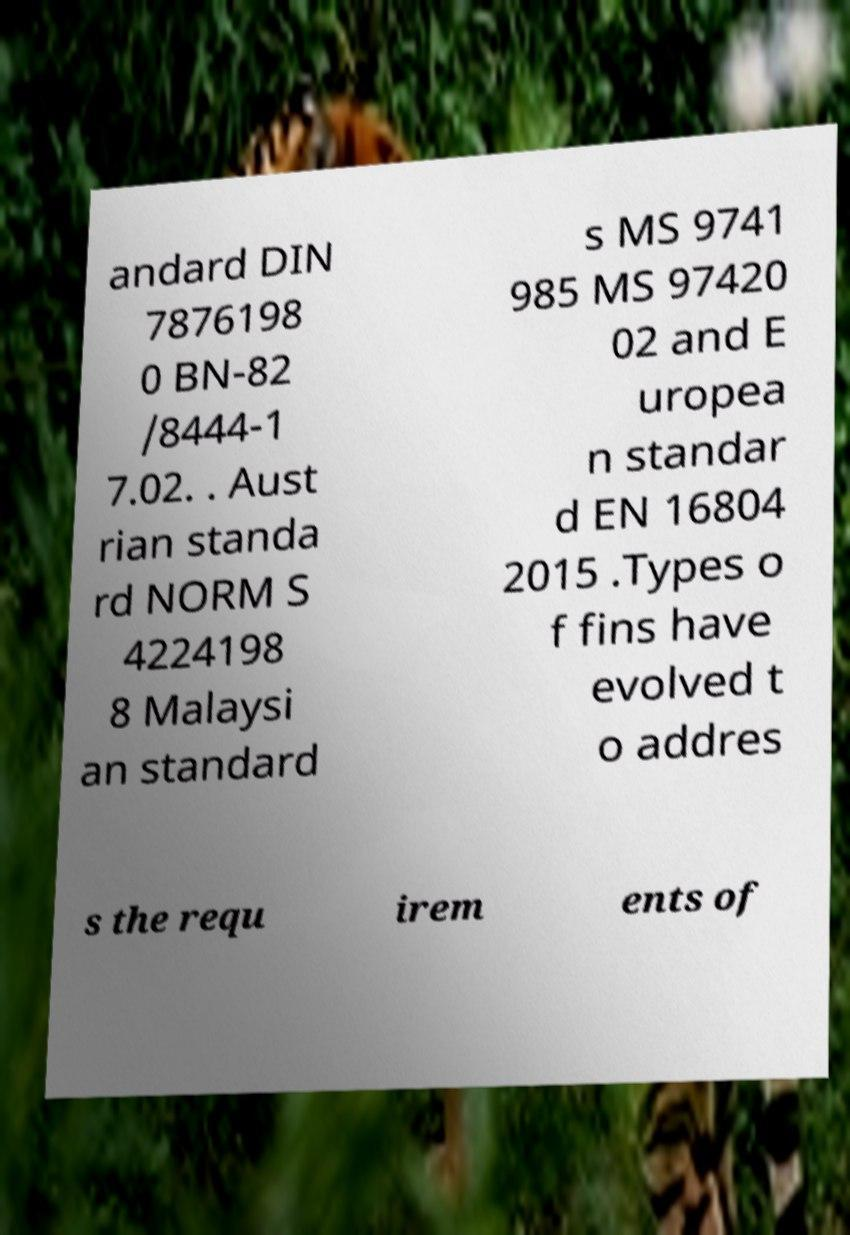For documentation purposes, I need the text within this image transcribed. Could you provide that? andard DIN 7876198 0 BN-82 /8444-1 7.02. . Aust rian standa rd NORM S 4224198 8 Malaysi an standard s MS 9741 985 MS 97420 02 and E uropea n standar d EN 16804 2015 .Types o f fins have evolved t o addres s the requ irem ents of 